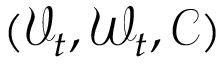<formula> <loc_0><loc_0><loc_500><loc_500>( \mathcal { V } _ { t } , \mathcal { W } _ { t } , \mathcal { C } )</formula> 